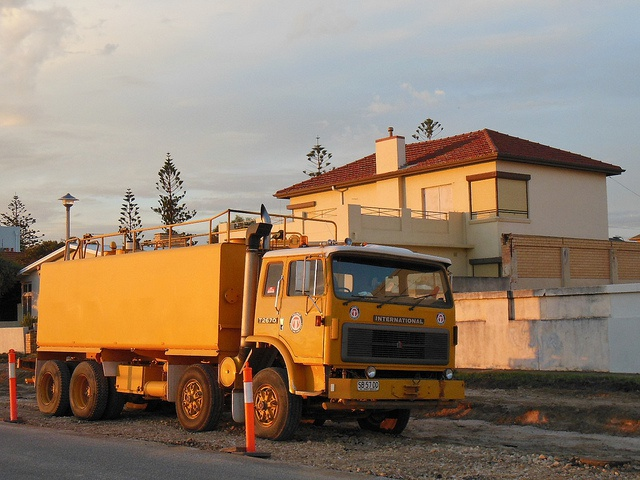Describe the objects in this image and their specific colors. I can see a truck in lightgray, orange, black, and maroon tones in this image. 